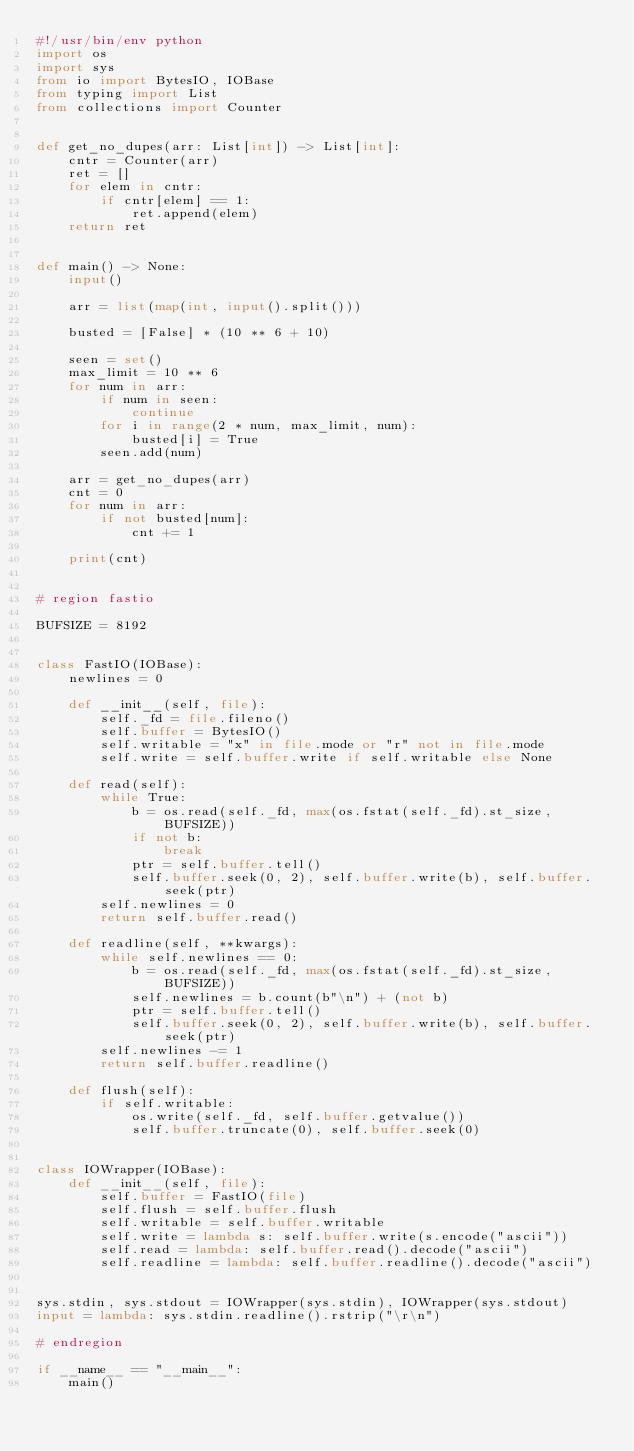<code> <loc_0><loc_0><loc_500><loc_500><_Python_>#!/usr/bin/env python
import os
import sys
from io import BytesIO, IOBase
from typing import List
from collections import Counter


def get_no_dupes(arr: List[int]) -> List[int]:
    cntr = Counter(arr)
    ret = []
    for elem in cntr:
        if cntr[elem] == 1:
            ret.append(elem)
    return ret


def main() -> None:
    input()

    arr = list(map(int, input().split()))

    busted = [False] * (10 ** 6 + 10)

    seen = set()
    max_limit = 10 ** 6
    for num in arr:
        if num in seen:
            continue
        for i in range(2 * num, max_limit, num):
            busted[i] = True
        seen.add(num)

    arr = get_no_dupes(arr)
    cnt = 0
    for num in arr:
        if not busted[num]:
            cnt += 1

    print(cnt)


# region fastio

BUFSIZE = 8192


class FastIO(IOBase):
    newlines = 0

    def __init__(self, file):
        self._fd = file.fileno()
        self.buffer = BytesIO()
        self.writable = "x" in file.mode or "r" not in file.mode
        self.write = self.buffer.write if self.writable else None

    def read(self):
        while True:
            b = os.read(self._fd, max(os.fstat(self._fd).st_size, BUFSIZE))
            if not b:
                break
            ptr = self.buffer.tell()
            self.buffer.seek(0, 2), self.buffer.write(b), self.buffer.seek(ptr)
        self.newlines = 0
        return self.buffer.read()

    def readline(self, **kwargs):
        while self.newlines == 0:
            b = os.read(self._fd, max(os.fstat(self._fd).st_size, BUFSIZE))
            self.newlines = b.count(b"\n") + (not b)
            ptr = self.buffer.tell()
            self.buffer.seek(0, 2), self.buffer.write(b), self.buffer.seek(ptr)
        self.newlines -= 1
        return self.buffer.readline()

    def flush(self):
        if self.writable:
            os.write(self._fd, self.buffer.getvalue())
            self.buffer.truncate(0), self.buffer.seek(0)


class IOWrapper(IOBase):
    def __init__(self, file):
        self.buffer = FastIO(file)
        self.flush = self.buffer.flush
        self.writable = self.buffer.writable
        self.write = lambda s: self.buffer.write(s.encode("ascii"))
        self.read = lambda: self.buffer.read().decode("ascii")
        self.readline = lambda: self.buffer.readline().decode("ascii")


sys.stdin, sys.stdout = IOWrapper(sys.stdin), IOWrapper(sys.stdout)
input = lambda: sys.stdin.readline().rstrip("\r\n")

# endregion

if __name__ == "__main__":
    main()
</code> 